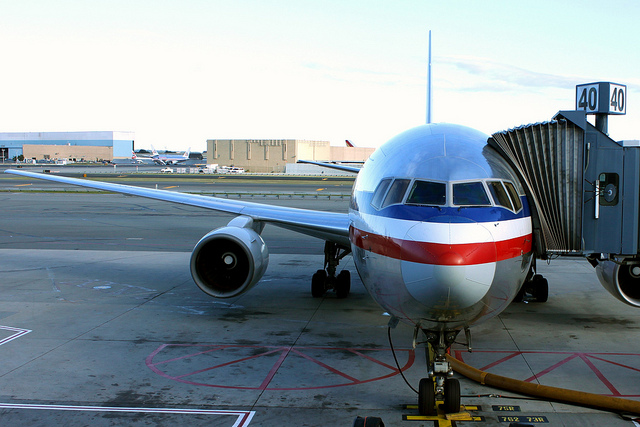Read and extract the text from this image. 40 40 752 